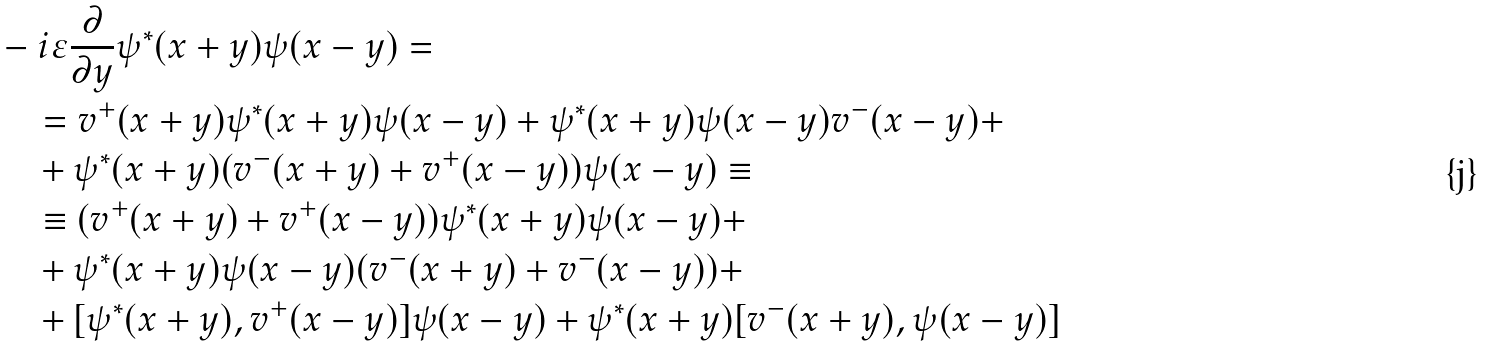<formula> <loc_0><loc_0><loc_500><loc_500>& - i \varepsilon \frac { \partial } { \partial y } \psi ^ { * } ( x + y ) \psi ( x - y ) = \\ & \quad = v ^ { + } ( x + y ) \psi ^ { * } ( x + y ) \psi ( x - y ) + \psi ^ { * } ( x + y ) \psi ( x - y ) v ^ { - } ( x - y ) + \\ & \quad + \psi ^ { * } ( x + y ) ( v ^ { - } ( x + y ) + v ^ { + } ( x - y ) ) \psi ( x - y ) \equiv \\ & \quad \equiv ( v ^ { + } ( x + y ) + v ^ { + } ( x - y ) ) \psi ^ { * } ( x + y ) \psi ( x - y ) + \\ & \quad + \psi ^ { * } ( x + y ) \psi ( x - y ) ( v ^ { - } ( x + y ) + v ^ { - } ( x - y ) ) + \\ & \quad + [ \psi ^ { * } ( x + y ) , v ^ { + } ( x - y ) ] \psi ( x - y ) + \psi ^ { * } ( x + y ) [ v ^ { - } ( x + y ) , \psi ( x - y ) ]</formula> 